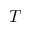Convert formula to latex. <formula><loc_0><loc_0><loc_500><loc_500>T</formula> 